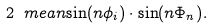<formula> <loc_0><loc_0><loc_500><loc_500>2 \ m e a n { \sin ( n \phi _ { i } ) \cdot \sin ( n \Phi _ { n } ) } .</formula> 